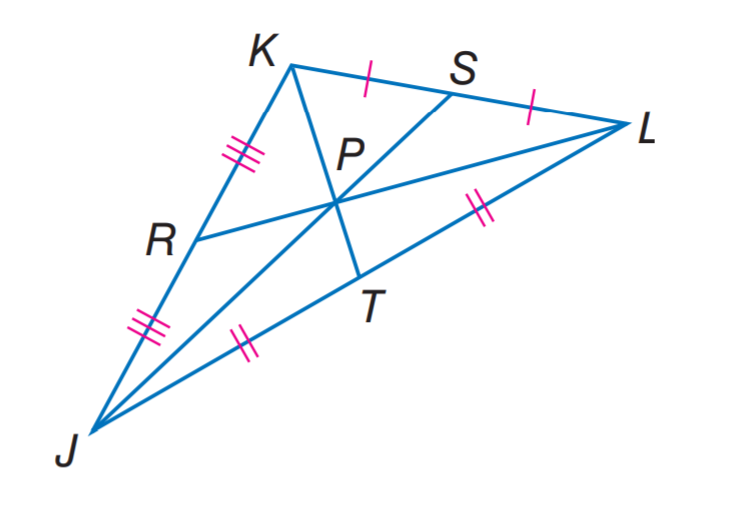Question: In \triangle J K L, P T = 2. Find K P.
Choices:
A. 2
B. 4
C. 6
D. 8
Answer with the letter. Answer: B Question: R P = 3.5 and J P = 9. Find P S.
Choices:
A. 3.5
B. 4.5
C. 7
D. 9
Answer with the letter. Answer: B Question: R P = 3.5 and J P = 9. Find P L.
Choices:
A. 3.5
B. 4.5
C. 7
D. 9
Answer with the letter. Answer: C 